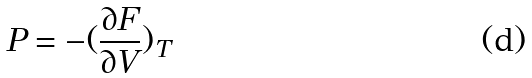Convert formula to latex. <formula><loc_0><loc_0><loc_500><loc_500>P = - ( \frac { \partial F } { \partial V } ) _ { T }</formula> 